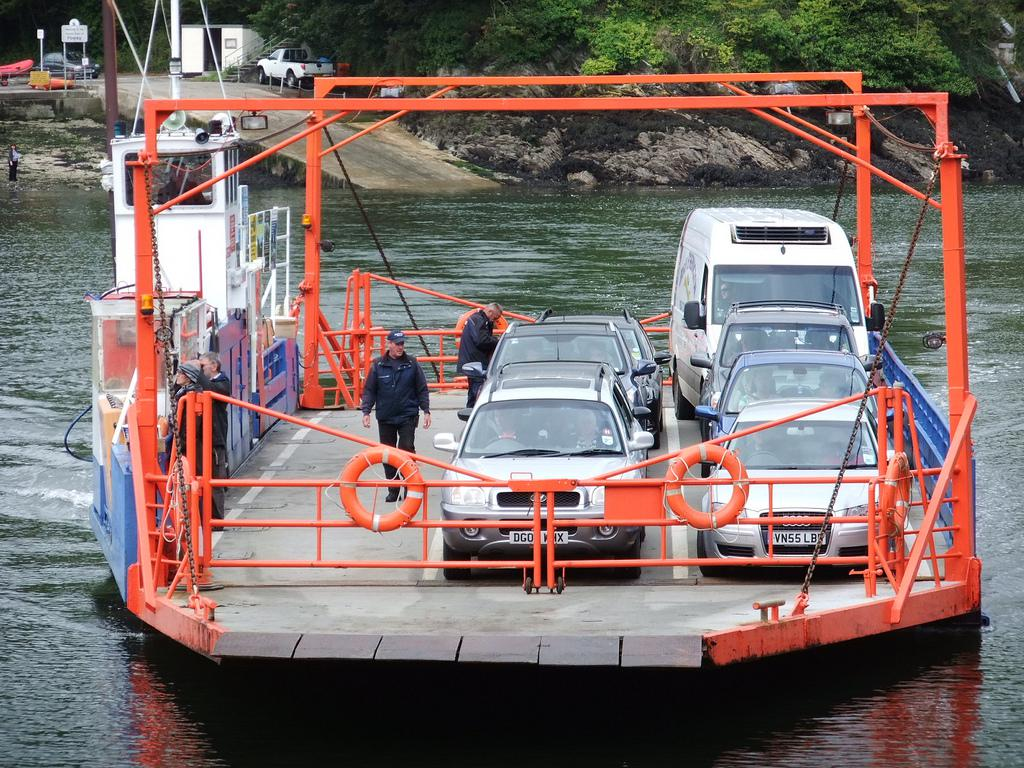Question: how were the cars being transported?
Choices:
A. By ferry.
B. By truck.
C. By plane.
D. With a tow truck.
Answer with the letter. Answer: A Question: what color was the ferry?
Choices:
A. Orange.
B. White.
C. Blue.
D. Black.
Answer with the letter. Answer: A Question: what was the weather like?
Choices:
A. Cold.
B. Chilly.
C. Clear.
D. Warm.
Answer with the letter. Answer: C Question: what color was the first man jacket?
Choices:
A. Blue.
B. White.
C. Black.
D. Orange.
Answer with the letter. Answer: A Question: why was this photo taken?
Choices:
A. For insurance purposes.
B. For memories.
C. To journalism.
D. To document the event.
Answer with the letter. Answer: B Question: who was in the car?
Choices:
A. The driver.
B. Passengers.
C. The man in blue.
D. That couple.
Answer with the letter. Answer: B Question: where was the photo taken?
Choices:
A. On the mountain.
B. By the skyscraper.
C. In the cave.
D. By the lake.
Answer with the letter. Answer: D Question: where did this picture take place?
Choices:
A. On canoe.
B. On kayak.
C. On surfboard.
D. On ferry.
Answer with the letter. Answer: D Question: what color is the metal cage?
Choices:
A. Orange.
B. White.
C. Black.
D. Red.
Answer with the letter. Answer: A Question: how many vehicles are on the ferry?
Choices:
A. Seven.
B. Six.
C. Five.
D. Four.
Answer with the letter. Answer: A Question: where are the cars?
Choices:
A. On the ferry.
B. In the impound lot.
C. On the street.
D. At the dealership.
Answer with the letter. Answer: A Question: how many white vans are there?
Choices:
A. Two.
B. One.
C. Three.
D. Four.
Answer with the letter. Answer: B Question: where are the trees?
Choices:
A. In the forest.
B. On the mountain.
C. Along the highway.
D. On the bank.
Answer with the letter. Answer: D Question: who is wearing black coats?
Choices:
A. The people chasing the others in white coats.
B. The police.
C. The military.
D. The men.
Answer with the letter. Answer: D Question: who is talking to someone in the car?
Choices:
A. Two women.
B. A police officer.
C. A mechanic.
D. One man.
Answer with the letter. Answer: D Question: what is going on?
Choices:
A. A semi is hauling freight.
B. A bus is carrying passangers.
C. A ferry is carrying cars.
D. A horse is pulling a cart.
Answer with the letter. Answer: C Question: where are the cars?
Choices:
A. On the street.
B. On the river.
C. On the bridge.
D. On the road.
Answer with the letter. Answer: B Question: how many vehicles are on the boat?
Choices:
A. Six.
B. Five.
C. Eight.
D. Seven.
Answer with the letter. Answer: A 